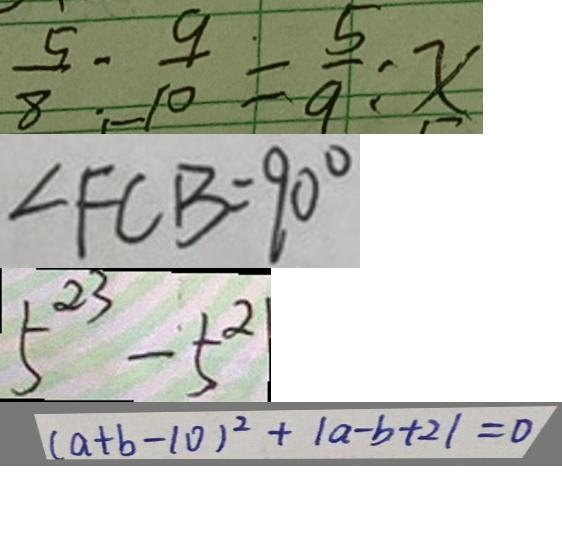Convert formula to latex. <formula><loc_0><loc_0><loc_500><loc_500>\frac { 5 } { 8 } o l o n \frac { 9 } { 1 0 } = \frac { 5 } { 9 } o l o n x 
 \angle F C B = 9 0 ^ { \circ } 
 5 ^ { 2 3 } - 5 ^ { 2 } 
 ( a + b - 1 0 ) ^ { 2 } + \vert a - b + 2 \vert = 0</formula> 